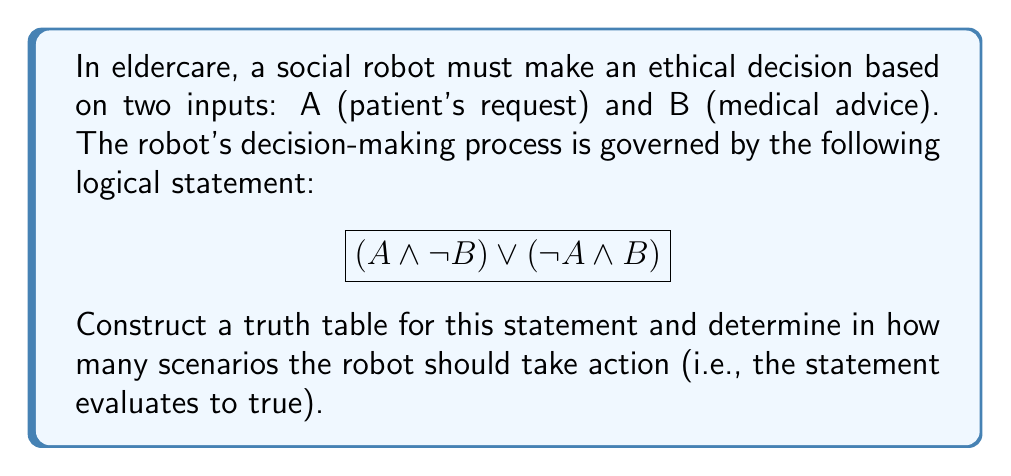Provide a solution to this math problem. To solve this problem, we need to construct a truth table and evaluate the given logical statement for all possible combinations of A and B. Let's break it down step by step:

1. Identify the variables: A and B
2. List all possible combinations of A and B (4 in total)
3. Evaluate each part of the expression:
   a. $(A \land \lnot B)$
   b. $(\lnot A \land B)$
4. Combine the results using the OR operator $\lor$

Here's the truth table:

$$
\begin{array}{|c|c|c|c|c|c|}
\hline
A & B & \lnot B & A \land \lnot B & \lnot A & \lnot A \land B & (A \land \lnot B) \lor (\lnot A \land B) \\
\hline
T & T & F & F & F & F & F \\
T & F & T & T & F & F & T \\
F & T & F & F & T & T & T \\
F & F & T & F & T & F & F \\
\hline
\end{array}
$$

Now, let's count the number of scenarios where the final result is true (T):

1. When A is true and B is false
2. When A is false and B is true

Therefore, there are 2 scenarios where the robot should take action based on this ethical decision-making process.
Answer: 2 scenarios 